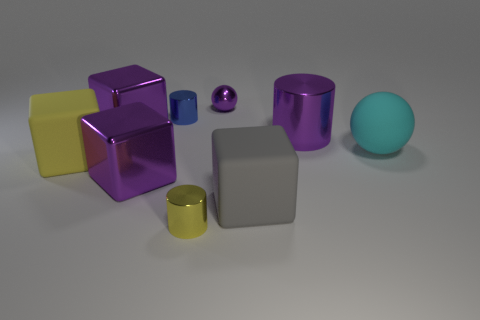What can you tell me about the different materials represented in this image? In this image, there is a diverse representation of materials. We have objects with metallic finishes, such as the purple and smaller yellow cylinders, which show reflective, smooth surfaces indicative of metal. Additionally, the big yellow cube and the smaller yellow cylinder seem to have rubber-like textures—dull and non-reflective. Lastly, there is at least one object, the blue sphere, that has a more matte, possibly plastic, finish given its slight translucency and non-reflective surface. 